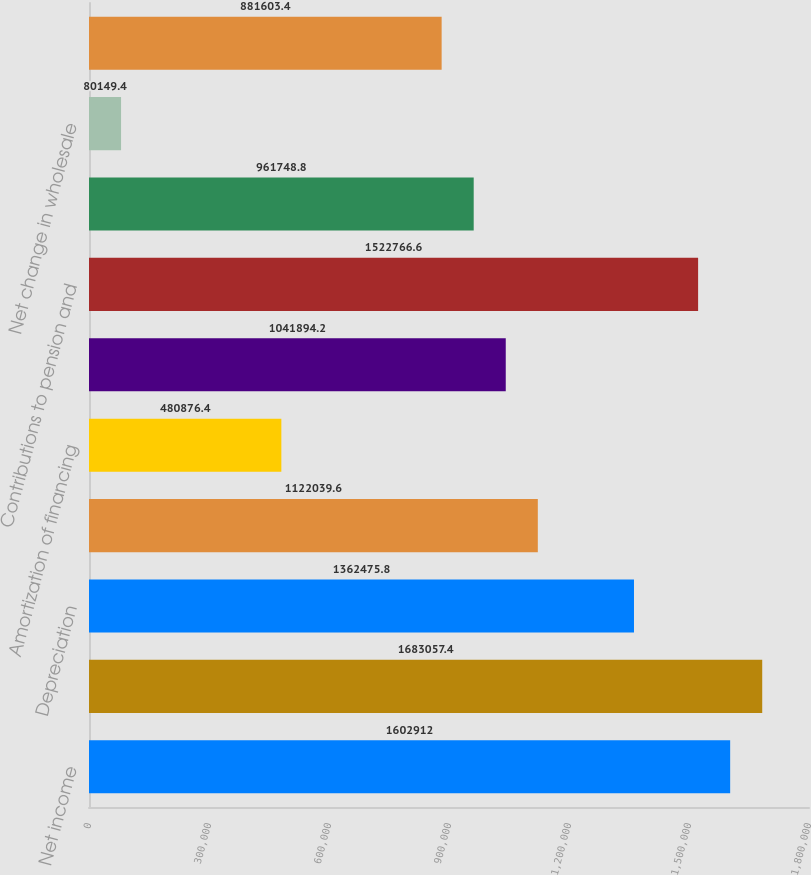<chart> <loc_0><loc_0><loc_500><loc_500><bar_chart><fcel>Net income<fcel>Income from continuing<fcel>Depreciation<fcel>Amortization of deferred loan<fcel>Amortization of financing<fcel>Provision for employee<fcel>Contributions to pension and<fcel>Stock compensation expense<fcel>Net change in wholesale<fcel>Provision for credit losses<nl><fcel>1.60291e+06<fcel>1.68306e+06<fcel>1.36248e+06<fcel>1.12204e+06<fcel>480876<fcel>1.04189e+06<fcel>1.52277e+06<fcel>961749<fcel>80149.4<fcel>881603<nl></chart> 